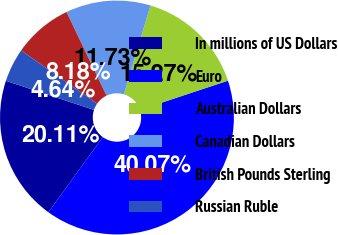<chart> <loc_0><loc_0><loc_500><loc_500><pie_chart><fcel>In millions of US Dollars<fcel>Euro<fcel>Australian Dollars<fcel>Canadian Dollars<fcel>British Pounds Sterling<fcel>Russian Ruble<nl><fcel>20.11%<fcel>40.07%<fcel>15.27%<fcel>11.73%<fcel>8.18%<fcel>4.64%<nl></chart> 